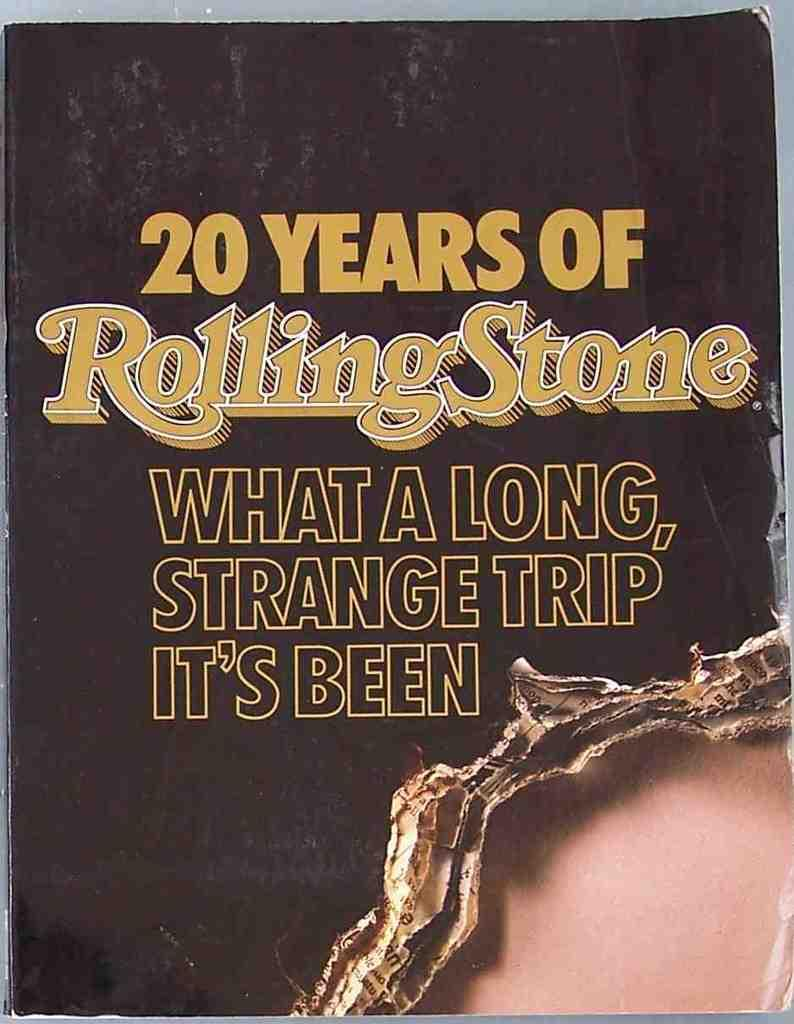Provide a one-sentence caption for the provided image. A very old copy of Rolling Stone is printed with What a Long, Strange Trip It's Been. 